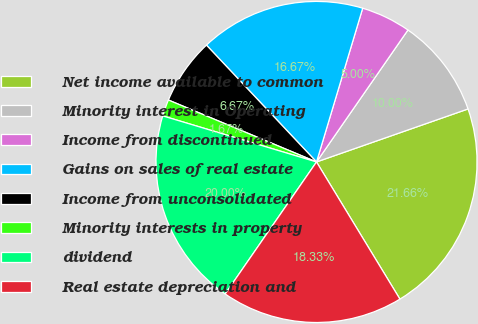<chart> <loc_0><loc_0><loc_500><loc_500><pie_chart><fcel>Net income available to common<fcel>Minority interest in Operating<fcel>Income from discontinued<fcel>Gains on sales of real estate<fcel>Income from unconsolidated<fcel>Minority interests in property<fcel>dividend<fcel>Real estate depreciation and<nl><fcel>21.66%<fcel>10.0%<fcel>5.0%<fcel>16.67%<fcel>6.67%<fcel>1.67%<fcel>20.0%<fcel>18.33%<nl></chart> 